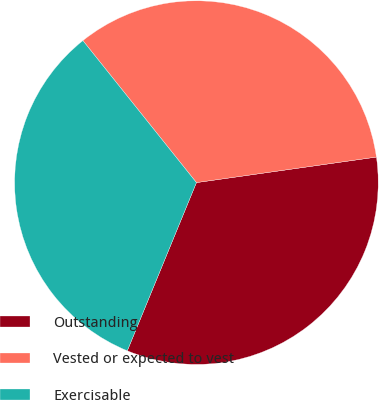Convert chart. <chart><loc_0><loc_0><loc_500><loc_500><pie_chart><fcel>Outstanding<fcel>Vested or expected to vest<fcel>Exercisable<nl><fcel>33.45%<fcel>33.49%<fcel>33.06%<nl></chart> 